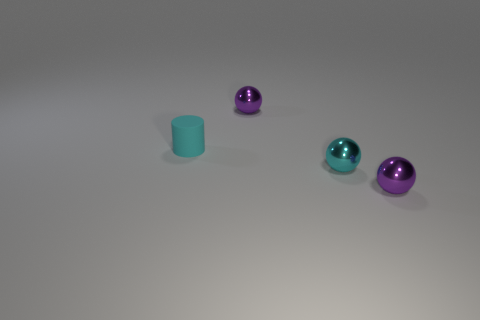Subtract all cyan balls. How many balls are left? 2 Subtract all gray cylinders. How many purple spheres are left? 2 Add 3 large brown objects. How many objects exist? 7 Subtract all cylinders. How many objects are left? 3 Subtract all green spheres. Subtract all gray cylinders. How many spheres are left? 3 Subtract all tiny cyan metal things. Subtract all cyan metallic balls. How many objects are left? 2 Add 1 cyan cylinders. How many cyan cylinders are left? 2 Add 1 cyan rubber objects. How many cyan rubber objects exist? 2 Subtract 1 cyan spheres. How many objects are left? 3 